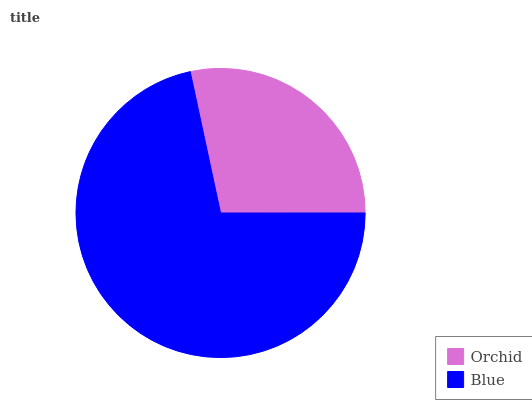Is Orchid the minimum?
Answer yes or no. Yes. Is Blue the maximum?
Answer yes or no. Yes. Is Blue the minimum?
Answer yes or no. No. Is Blue greater than Orchid?
Answer yes or no. Yes. Is Orchid less than Blue?
Answer yes or no. Yes. Is Orchid greater than Blue?
Answer yes or no. No. Is Blue less than Orchid?
Answer yes or no. No. Is Blue the high median?
Answer yes or no. Yes. Is Orchid the low median?
Answer yes or no. Yes. Is Orchid the high median?
Answer yes or no. No. Is Blue the low median?
Answer yes or no. No. 